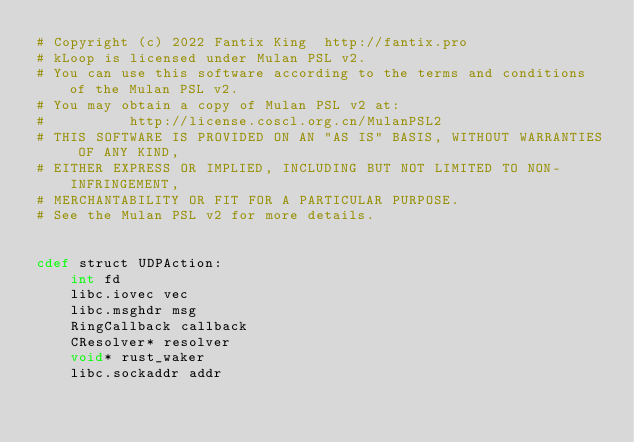Convert code to text. <code><loc_0><loc_0><loc_500><loc_500><_Cython_># Copyright (c) 2022 Fantix King  http://fantix.pro
# kLoop is licensed under Mulan PSL v2.
# You can use this software according to the terms and conditions of the Mulan PSL v2.
# You may obtain a copy of Mulan PSL v2 at:
#          http://license.coscl.org.cn/MulanPSL2
# THIS SOFTWARE IS PROVIDED ON AN "AS IS" BASIS, WITHOUT WARRANTIES OF ANY KIND,
# EITHER EXPRESS OR IMPLIED, INCLUDING BUT NOT LIMITED TO NON-INFRINGEMENT,
# MERCHANTABILITY OR FIT FOR A PARTICULAR PURPOSE.
# See the Mulan PSL v2 for more details.


cdef struct UDPAction:
    int fd
    libc.iovec vec
    libc.msghdr msg
    RingCallback callback
    CResolver* resolver
    void* rust_waker
    libc.sockaddr addr
</code> 